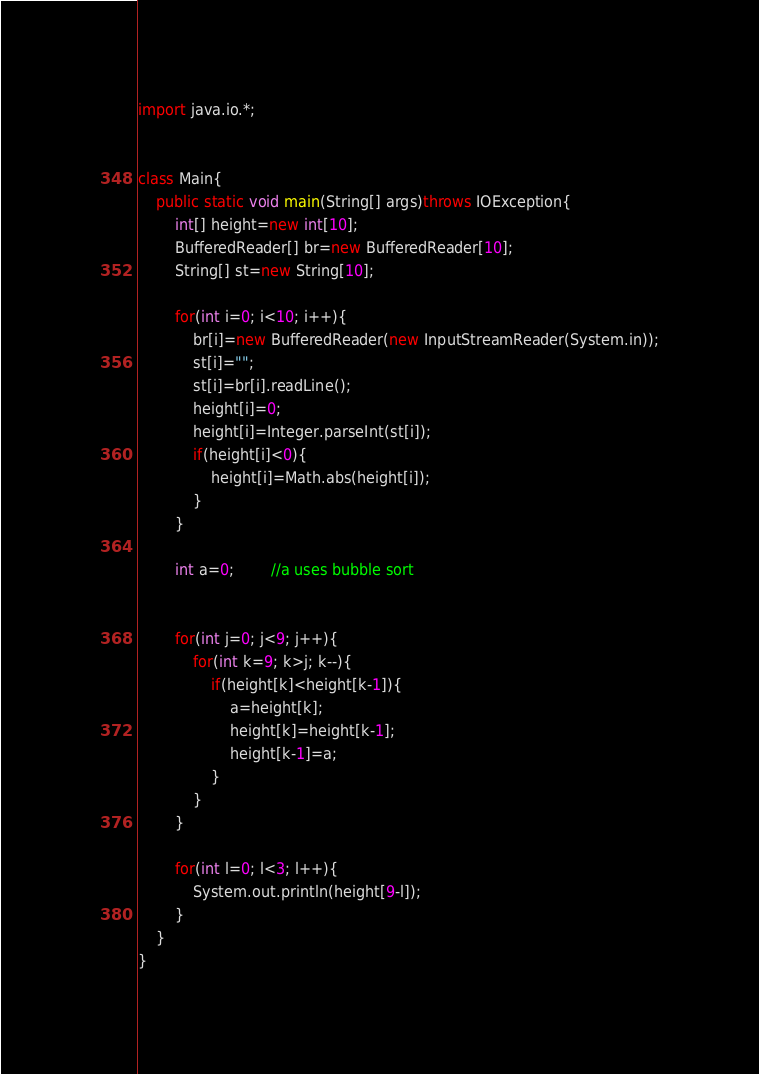Convert code to text. <code><loc_0><loc_0><loc_500><loc_500><_Java_>import java.io.*;


class Main{
	public static void main(String[] args)throws IOException{
		int[] height=new int[10];
		BufferedReader[] br=new BufferedReader[10];
		String[] st=new String[10];

		for(int i=0; i<10; i++){
			br[i]=new BufferedReader(new InputStreamReader(System.in));
			st[i]="";
			st[i]=br[i].readLine();
			height[i]=0;
			height[i]=Integer.parseInt(st[i]);
			if(height[i]<0){
				height[i]=Math.abs(height[i]);
			}
		}

		int a=0;		//a uses bubble sort


		for(int j=0; j<9; j++){
			for(int k=9; k>j; k--){
				if(height[k]<height[k-1]){
					a=height[k];
					height[k]=height[k-1];
					height[k-1]=a;
				}
			}
		}

		for(int l=0; l<3; l++){
			System.out.println(height[9-l]);
		}
	}
}</code> 